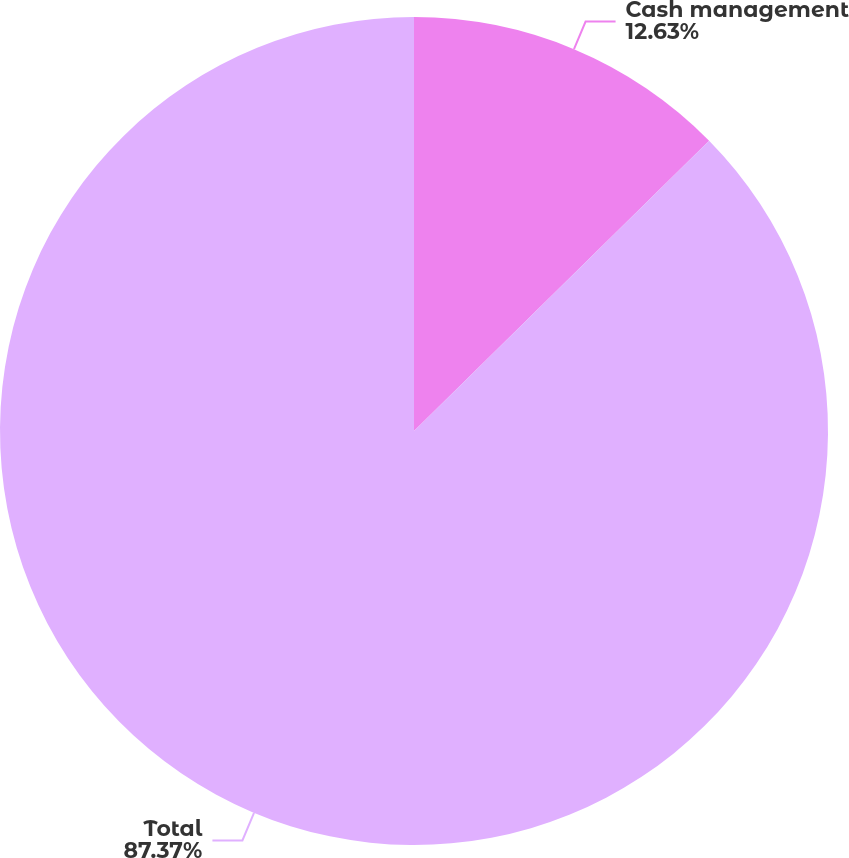<chart> <loc_0><loc_0><loc_500><loc_500><pie_chart><fcel>Cash management<fcel>Total<nl><fcel>12.63%<fcel>87.37%<nl></chart> 